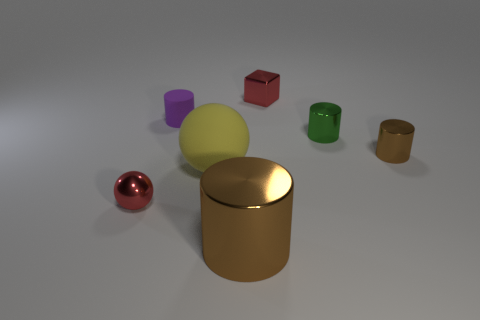Add 1 large red metal blocks. How many objects exist? 8 Subtract all spheres. How many objects are left? 5 Subtract 0 brown blocks. How many objects are left? 7 Subtract all big gray shiny cubes. Subtract all small brown shiny things. How many objects are left? 6 Add 1 purple matte cylinders. How many purple matte cylinders are left? 2 Add 4 green balls. How many green balls exist? 4 